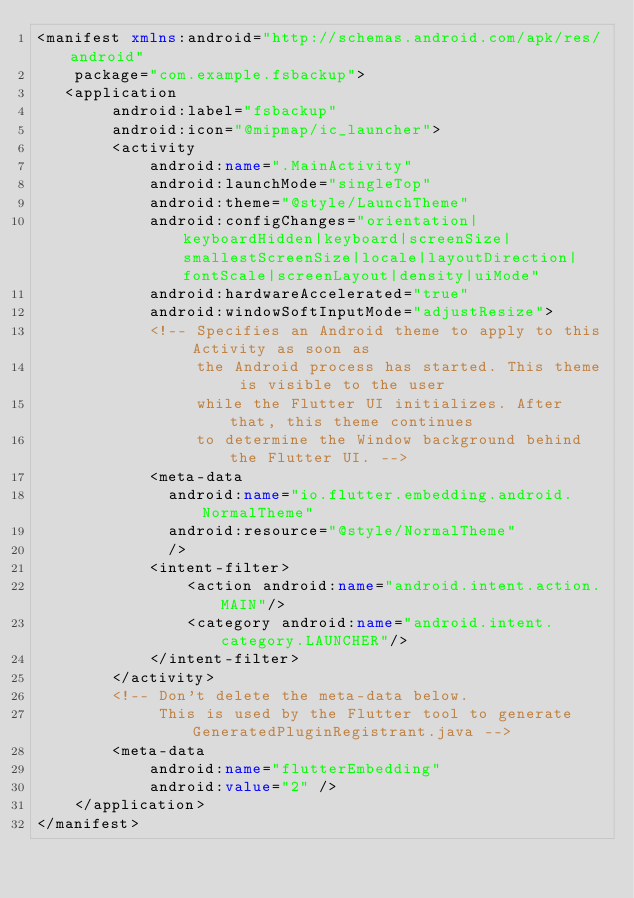Convert code to text. <code><loc_0><loc_0><loc_500><loc_500><_XML_><manifest xmlns:android="http://schemas.android.com/apk/res/android"
    package="com.example.fsbackup">
   <application
        android:label="fsbackup"
        android:icon="@mipmap/ic_launcher">
        <activity
            android:name=".MainActivity"
            android:launchMode="singleTop"
            android:theme="@style/LaunchTheme"
            android:configChanges="orientation|keyboardHidden|keyboard|screenSize|smallestScreenSize|locale|layoutDirection|fontScale|screenLayout|density|uiMode"
            android:hardwareAccelerated="true"
            android:windowSoftInputMode="adjustResize">
            <!-- Specifies an Android theme to apply to this Activity as soon as
                 the Android process has started. This theme is visible to the user
                 while the Flutter UI initializes. After that, this theme continues
                 to determine the Window background behind the Flutter UI. -->
            <meta-data
              android:name="io.flutter.embedding.android.NormalTheme"
              android:resource="@style/NormalTheme"
              />
            <intent-filter>
                <action android:name="android.intent.action.MAIN"/>
                <category android:name="android.intent.category.LAUNCHER"/>
            </intent-filter>
        </activity>
        <!-- Don't delete the meta-data below.
             This is used by the Flutter tool to generate GeneratedPluginRegistrant.java -->
        <meta-data
            android:name="flutterEmbedding"
            android:value="2" />
    </application>
</manifest>
</code> 